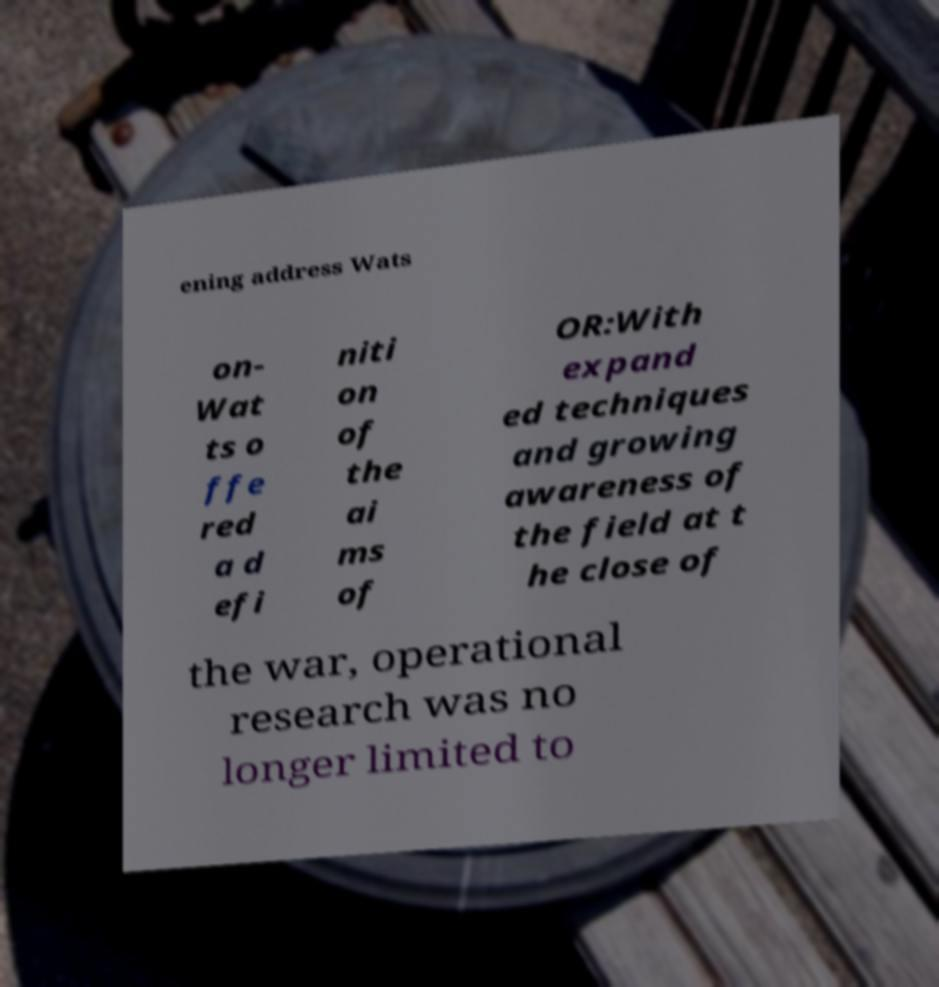For documentation purposes, I need the text within this image transcribed. Could you provide that? ening address Wats on- Wat ts o ffe red a d efi niti on of the ai ms of OR:With expand ed techniques and growing awareness of the field at t he close of the war, operational research was no longer limited to 